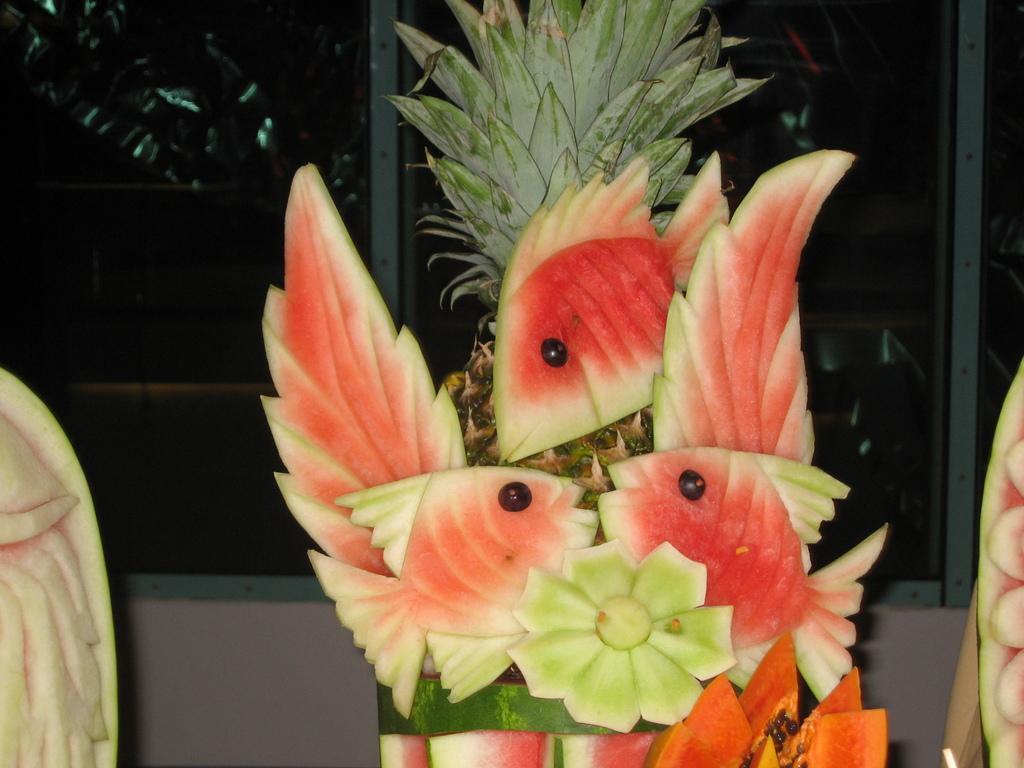Please provide a concise description of this image. In this image there is fruit craft, there are fisheś made of Watermelon, there is Pineapple, there are windowś, there is a wall. 